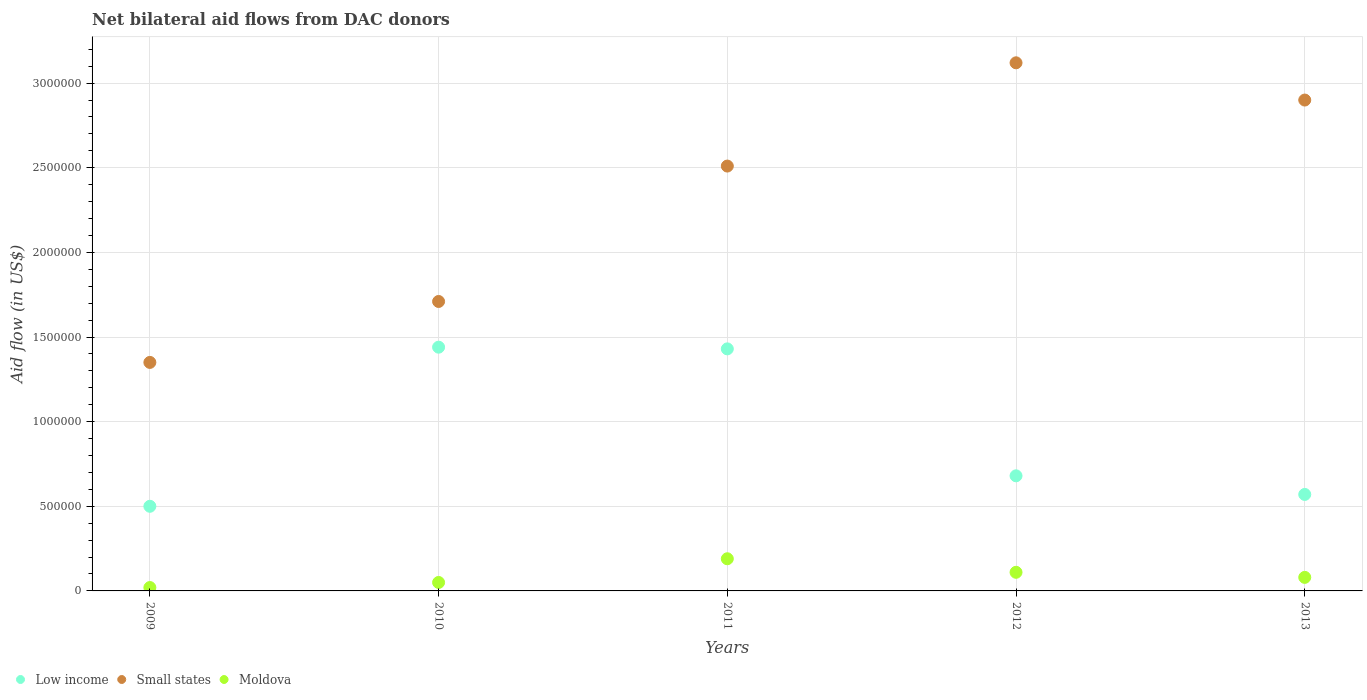How many different coloured dotlines are there?
Provide a short and direct response. 3. What is the net bilateral aid flow in Small states in 2012?
Offer a very short reply. 3.12e+06. Across all years, what is the maximum net bilateral aid flow in Small states?
Your answer should be compact. 3.12e+06. Across all years, what is the minimum net bilateral aid flow in Small states?
Provide a short and direct response. 1.35e+06. In which year was the net bilateral aid flow in Small states minimum?
Your answer should be compact. 2009. What is the total net bilateral aid flow in Moldova in the graph?
Offer a very short reply. 4.50e+05. What is the difference between the net bilateral aid flow in Small states in 2011 and that in 2012?
Offer a terse response. -6.10e+05. What is the difference between the net bilateral aid flow in Low income in 2010 and the net bilateral aid flow in Moldova in 2009?
Make the answer very short. 1.42e+06. What is the average net bilateral aid flow in Small states per year?
Provide a short and direct response. 2.32e+06. In the year 2012, what is the difference between the net bilateral aid flow in Low income and net bilateral aid flow in Small states?
Offer a very short reply. -2.44e+06. What is the ratio of the net bilateral aid flow in Small states in 2010 to that in 2013?
Offer a very short reply. 0.59. Is the difference between the net bilateral aid flow in Low income in 2010 and 2011 greater than the difference between the net bilateral aid flow in Small states in 2010 and 2011?
Provide a short and direct response. Yes. What is the difference between the highest and the lowest net bilateral aid flow in Low income?
Provide a succinct answer. 9.40e+05. In how many years, is the net bilateral aid flow in Low income greater than the average net bilateral aid flow in Low income taken over all years?
Keep it short and to the point. 2. Is the sum of the net bilateral aid flow in Moldova in 2010 and 2012 greater than the maximum net bilateral aid flow in Low income across all years?
Give a very brief answer. No. Does the net bilateral aid flow in Small states monotonically increase over the years?
Your answer should be very brief. No. Is the net bilateral aid flow in Moldova strictly less than the net bilateral aid flow in Small states over the years?
Give a very brief answer. Yes. What is the difference between two consecutive major ticks on the Y-axis?
Offer a terse response. 5.00e+05. Are the values on the major ticks of Y-axis written in scientific E-notation?
Make the answer very short. No. Where does the legend appear in the graph?
Offer a terse response. Bottom left. How many legend labels are there?
Keep it short and to the point. 3. What is the title of the graph?
Your answer should be very brief. Net bilateral aid flows from DAC donors. Does "Cabo Verde" appear as one of the legend labels in the graph?
Provide a succinct answer. No. What is the label or title of the X-axis?
Your answer should be compact. Years. What is the label or title of the Y-axis?
Offer a terse response. Aid flow (in US$). What is the Aid flow (in US$) in Small states in 2009?
Offer a very short reply. 1.35e+06. What is the Aid flow (in US$) in Moldova in 2009?
Make the answer very short. 2.00e+04. What is the Aid flow (in US$) in Low income in 2010?
Ensure brevity in your answer.  1.44e+06. What is the Aid flow (in US$) of Small states in 2010?
Keep it short and to the point. 1.71e+06. What is the Aid flow (in US$) of Moldova in 2010?
Provide a succinct answer. 5.00e+04. What is the Aid flow (in US$) of Low income in 2011?
Make the answer very short. 1.43e+06. What is the Aid flow (in US$) of Small states in 2011?
Provide a succinct answer. 2.51e+06. What is the Aid flow (in US$) of Moldova in 2011?
Make the answer very short. 1.90e+05. What is the Aid flow (in US$) of Low income in 2012?
Provide a short and direct response. 6.80e+05. What is the Aid flow (in US$) of Small states in 2012?
Your response must be concise. 3.12e+06. What is the Aid flow (in US$) in Moldova in 2012?
Make the answer very short. 1.10e+05. What is the Aid flow (in US$) of Low income in 2013?
Your answer should be compact. 5.70e+05. What is the Aid flow (in US$) in Small states in 2013?
Make the answer very short. 2.90e+06. Across all years, what is the maximum Aid flow (in US$) of Low income?
Offer a very short reply. 1.44e+06. Across all years, what is the maximum Aid flow (in US$) of Small states?
Give a very brief answer. 3.12e+06. Across all years, what is the minimum Aid flow (in US$) in Low income?
Keep it short and to the point. 5.00e+05. Across all years, what is the minimum Aid flow (in US$) of Small states?
Offer a very short reply. 1.35e+06. Across all years, what is the minimum Aid flow (in US$) of Moldova?
Offer a terse response. 2.00e+04. What is the total Aid flow (in US$) in Low income in the graph?
Provide a succinct answer. 4.62e+06. What is the total Aid flow (in US$) of Small states in the graph?
Provide a succinct answer. 1.16e+07. What is the difference between the Aid flow (in US$) of Low income in 2009 and that in 2010?
Give a very brief answer. -9.40e+05. What is the difference between the Aid flow (in US$) in Small states in 2009 and that in 2010?
Offer a terse response. -3.60e+05. What is the difference between the Aid flow (in US$) in Moldova in 2009 and that in 2010?
Your answer should be very brief. -3.00e+04. What is the difference between the Aid flow (in US$) in Low income in 2009 and that in 2011?
Provide a succinct answer. -9.30e+05. What is the difference between the Aid flow (in US$) of Small states in 2009 and that in 2011?
Your answer should be very brief. -1.16e+06. What is the difference between the Aid flow (in US$) of Low income in 2009 and that in 2012?
Provide a succinct answer. -1.80e+05. What is the difference between the Aid flow (in US$) of Small states in 2009 and that in 2012?
Your response must be concise. -1.77e+06. What is the difference between the Aid flow (in US$) in Moldova in 2009 and that in 2012?
Your answer should be compact. -9.00e+04. What is the difference between the Aid flow (in US$) in Small states in 2009 and that in 2013?
Your answer should be very brief. -1.55e+06. What is the difference between the Aid flow (in US$) in Moldova in 2009 and that in 2013?
Your response must be concise. -6.00e+04. What is the difference between the Aid flow (in US$) of Small states in 2010 and that in 2011?
Your response must be concise. -8.00e+05. What is the difference between the Aid flow (in US$) of Moldova in 2010 and that in 2011?
Ensure brevity in your answer.  -1.40e+05. What is the difference between the Aid flow (in US$) in Low income in 2010 and that in 2012?
Your answer should be very brief. 7.60e+05. What is the difference between the Aid flow (in US$) of Small states in 2010 and that in 2012?
Offer a terse response. -1.41e+06. What is the difference between the Aid flow (in US$) in Low income in 2010 and that in 2013?
Your answer should be very brief. 8.70e+05. What is the difference between the Aid flow (in US$) in Small states in 2010 and that in 2013?
Offer a terse response. -1.19e+06. What is the difference between the Aid flow (in US$) of Low income in 2011 and that in 2012?
Your response must be concise. 7.50e+05. What is the difference between the Aid flow (in US$) of Small states in 2011 and that in 2012?
Your answer should be very brief. -6.10e+05. What is the difference between the Aid flow (in US$) in Moldova in 2011 and that in 2012?
Offer a terse response. 8.00e+04. What is the difference between the Aid flow (in US$) in Low income in 2011 and that in 2013?
Provide a short and direct response. 8.60e+05. What is the difference between the Aid flow (in US$) of Small states in 2011 and that in 2013?
Offer a very short reply. -3.90e+05. What is the difference between the Aid flow (in US$) of Moldova in 2011 and that in 2013?
Provide a short and direct response. 1.10e+05. What is the difference between the Aid flow (in US$) of Small states in 2012 and that in 2013?
Provide a succinct answer. 2.20e+05. What is the difference between the Aid flow (in US$) of Moldova in 2012 and that in 2013?
Ensure brevity in your answer.  3.00e+04. What is the difference between the Aid flow (in US$) of Low income in 2009 and the Aid flow (in US$) of Small states in 2010?
Offer a terse response. -1.21e+06. What is the difference between the Aid flow (in US$) of Low income in 2009 and the Aid flow (in US$) of Moldova in 2010?
Make the answer very short. 4.50e+05. What is the difference between the Aid flow (in US$) in Small states in 2009 and the Aid flow (in US$) in Moldova in 2010?
Your answer should be very brief. 1.30e+06. What is the difference between the Aid flow (in US$) of Low income in 2009 and the Aid flow (in US$) of Small states in 2011?
Ensure brevity in your answer.  -2.01e+06. What is the difference between the Aid flow (in US$) in Low income in 2009 and the Aid flow (in US$) in Moldova in 2011?
Make the answer very short. 3.10e+05. What is the difference between the Aid flow (in US$) of Small states in 2009 and the Aid flow (in US$) of Moldova in 2011?
Offer a terse response. 1.16e+06. What is the difference between the Aid flow (in US$) of Low income in 2009 and the Aid flow (in US$) of Small states in 2012?
Keep it short and to the point. -2.62e+06. What is the difference between the Aid flow (in US$) of Low income in 2009 and the Aid flow (in US$) of Moldova in 2012?
Ensure brevity in your answer.  3.90e+05. What is the difference between the Aid flow (in US$) of Small states in 2009 and the Aid flow (in US$) of Moldova in 2012?
Your answer should be compact. 1.24e+06. What is the difference between the Aid flow (in US$) in Low income in 2009 and the Aid flow (in US$) in Small states in 2013?
Provide a short and direct response. -2.40e+06. What is the difference between the Aid flow (in US$) of Low income in 2009 and the Aid flow (in US$) of Moldova in 2013?
Ensure brevity in your answer.  4.20e+05. What is the difference between the Aid flow (in US$) in Small states in 2009 and the Aid flow (in US$) in Moldova in 2013?
Ensure brevity in your answer.  1.27e+06. What is the difference between the Aid flow (in US$) of Low income in 2010 and the Aid flow (in US$) of Small states in 2011?
Keep it short and to the point. -1.07e+06. What is the difference between the Aid flow (in US$) of Low income in 2010 and the Aid flow (in US$) of Moldova in 2011?
Your response must be concise. 1.25e+06. What is the difference between the Aid flow (in US$) in Small states in 2010 and the Aid flow (in US$) in Moldova in 2011?
Provide a short and direct response. 1.52e+06. What is the difference between the Aid flow (in US$) of Low income in 2010 and the Aid flow (in US$) of Small states in 2012?
Your response must be concise. -1.68e+06. What is the difference between the Aid flow (in US$) in Low income in 2010 and the Aid flow (in US$) in Moldova in 2012?
Your answer should be compact. 1.33e+06. What is the difference between the Aid flow (in US$) of Small states in 2010 and the Aid flow (in US$) of Moldova in 2012?
Your response must be concise. 1.60e+06. What is the difference between the Aid flow (in US$) in Low income in 2010 and the Aid flow (in US$) in Small states in 2013?
Make the answer very short. -1.46e+06. What is the difference between the Aid flow (in US$) of Low income in 2010 and the Aid flow (in US$) of Moldova in 2013?
Provide a succinct answer. 1.36e+06. What is the difference between the Aid flow (in US$) in Small states in 2010 and the Aid flow (in US$) in Moldova in 2013?
Ensure brevity in your answer.  1.63e+06. What is the difference between the Aid flow (in US$) of Low income in 2011 and the Aid flow (in US$) of Small states in 2012?
Ensure brevity in your answer.  -1.69e+06. What is the difference between the Aid flow (in US$) in Low income in 2011 and the Aid flow (in US$) in Moldova in 2012?
Offer a very short reply. 1.32e+06. What is the difference between the Aid flow (in US$) of Small states in 2011 and the Aid flow (in US$) of Moldova in 2012?
Keep it short and to the point. 2.40e+06. What is the difference between the Aid flow (in US$) of Low income in 2011 and the Aid flow (in US$) of Small states in 2013?
Make the answer very short. -1.47e+06. What is the difference between the Aid flow (in US$) in Low income in 2011 and the Aid flow (in US$) in Moldova in 2013?
Keep it short and to the point. 1.35e+06. What is the difference between the Aid flow (in US$) in Small states in 2011 and the Aid flow (in US$) in Moldova in 2013?
Provide a short and direct response. 2.43e+06. What is the difference between the Aid flow (in US$) of Low income in 2012 and the Aid flow (in US$) of Small states in 2013?
Your response must be concise. -2.22e+06. What is the difference between the Aid flow (in US$) of Small states in 2012 and the Aid flow (in US$) of Moldova in 2013?
Provide a short and direct response. 3.04e+06. What is the average Aid flow (in US$) in Low income per year?
Your response must be concise. 9.24e+05. What is the average Aid flow (in US$) of Small states per year?
Provide a short and direct response. 2.32e+06. In the year 2009, what is the difference between the Aid flow (in US$) in Low income and Aid flow (in US$) in Small states?
Offer a very short reply. -8.50e+05. In the year 2009, what is the difference between the Aid flow (in US$) in Small states and Aid flow (in US$) in Moldova?
Provide a succinct answer. 1.33e+06. In the year 2010, what is the difference between the Aid flow (in US$) of Low income and Aid flow (in US$) of Moldova?
Offer a very short reply. 1.39e+06. In the year 2010, what is the difference between the Aid flow (in US$) in Small states and Aid flow (in US$) in Moldova?
Give a very brief answer. 1.66e+06. In the year 2011, what is the difference between the Aid flow (in US$) in Low income and Aid flow (in US$) in Small states?
Give a very brief answer. -1.08e+06. In the year 2011, what is the difference between the Aid flow (in US$) of Low income and Aid flow (in US$) of Moldova?
Ensure brevity in your answer.  1.24e+06. In the year 2011, what is the difference between the Aid flow (in US$) in Small states and Aid flow (in US$) in Moldova?
Ensure brevity in your answer.  2.32e+06. In the year 2012, what is the difference between the Aid flow (in US$) of Low income and Aid flow (in US$) of Small states?
Provide a short and direct response. -2.44e+06. In the year 2012, what is the difference between the Aid flow (in US$) in Low income and Aid flow (in US$) in Moldova?
Your response must be concise. 5.70e+05. In the year 2012, what is the difference between the Aid flow (in US$) in Small states and Aid flow (in US$) in Moldova?
Your answer should be very brief. 3.01e+06. In the year 2013, what is the difference between the Aid flow (in US$) of Low income and Aid flow (in US$) of Small states?
Give a very brief answer. -2.33e+06. In the year 2013, what is the difference between the Aid flow (in US$) of Low income and Aid flow (in US$) of Moldova?
Offer a terse response. 4.90e+05. In the year 2013, what is the difference between the Aid flow (in US$) in Small states and Aid flow (in US$) in Moldova?
Keep it short and to the point. 2.82e+06. What is the ratio of the Aid flow (in US$) in Low income in 2009 to that in 2010?
Offer a very short reply. 0.35. What is the ratio of the Aid flow (in US$) of Small states in 2009 to that in 2010?
Provide a short and direct response. 0.79. What is the ratio of the Aid flow (in US$) in Low income in 2009 to that in 2011?
Ensure brevity in your answer.  0.35. What is the ratio of the Aid flow (in US$) in Small states in 2009 to that in 2011?
Offer a very short reply. 0.54. What is the ratio of the Aid flow (in US$) in Moldova in 2009 to that in 2011?
Keep it short and to the point. 0.11. What is the ratio of the Aid flow (in US$) in Low income in 2009 to that in 2012?
Your response must be concise. 0.74. What is the ratio of the Aid flow (in US$) in Small states in 2009 to that in 2012?
Ensure brevity in your answer.  0.43. What is the ratio of the Aid flow (in US$) of Moldova in 2009 to that in 2012?
Provide a short and direct response. 0.18. What is the ratio of the Aid flow (in US$) of Low income in 2009 to that in 2013?
Give a very brief answer. 0.88. What is the ratio of the Aid flow (in US$) in Small states in 2009 to that in 2013?
Make the answer very short. 0.47. What is the ratio of the Aid flow (in US$) in Moldova in 2009 to that in 2013?
Provide a succinct answer. 0.25. What is the ratio of the Aid flow (in US$) of Small states in 2010 to that in 2011?
Your answer should be compact. 0.68. What is the ratio of the Aid flow (in US$) of Moldova in 2010 to that in 2011?
Keep it short and to the point. 0.26. What is the ratio of the Aid flow (in US$) of Low income in 2010 to that in 2012?
Ensure brevity in your answer.  2.12. What is the ratio of the Aid flow (in US$) of Small states in 2010 to that in 2012?
Offer a terse response. 0.55. What is the ratio of the Aid flow (in US$) in Moldova in 2010 to that in 2012?
Offer a terse response. 0.45. What is the ratio of the Aid flow (in US$) in Low income in 2010 to that in 2013?
Keep it short and to the point. 2.53. What is the ratio of the Aid flow (in US$) of Small states in 2010 to that in 2013?
Offer a terse response. 0.59. What is the ratio of the Aid flow (in US$) in Low income in 2011 to that in 2012?
Offer a terse response. 2.1. What is the ratio of the Aid flow (in US$) in Small states in 2011 to that in 2012?
Make the answer very short. 0.8. What is the ratio of the Aid flow (in US$) of Moldova in 2011 to that in 2012?
Your answer should be very brief. 1.73. What is the ratio of the Aid flow (in US$) of Low income in 2011 to that in 2013?
Make the answer very short. 2.51. What is the ratio of the Aid flow (in US$) of Small states in 2011 to that in 2013?
Provide a succinct answer. 0.87. What is the ratio of the Aid flow (in US$) of Moldova in 2011 to that in 2013?
Offer a terse response. 2.38. What is the ratio of the Aid flow (in US$) in Low income in 2012 to that in 2013?
Provide a succinct answer. 1.19. What is the ratio of the Aid flow (in US$) of Small states in 2012 to that in 2013?
Offer a very short reply. 1.08. What is the ratio of the Aid flow (in US$) in Moldova in 2012 to that in 2013?
Provide a succinct answer. 1.38. What is the difference between the highest and the second highest Aid flow (in US$) in Low income?
Give a very brief answer. 10000. What is the difference between the highest and the second highest Aid flow (in US$) of Moldova?
Provide a short and direct response. 8.00e+04. What is the difference between the highest and the lowest Aid flow (in US$) of Low income?
Offer a terse response. 9.40e+05. What is the difference between the highest and the lowest Aid flow (in US$) in Small states?
Provide a succinct answer. 1.77e+06. What is the difference between the highest and the lowest Aid flow (in US$) of Moldova?
Your response must be concise. 1.70e+05. 